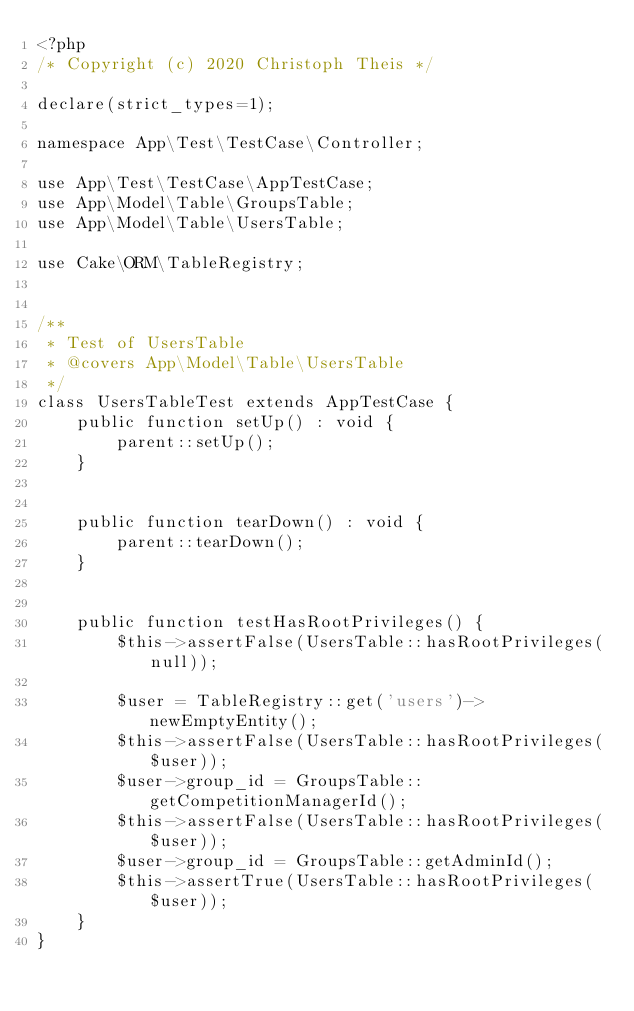Convert code to text. <code><loc_0><loc_0><loc_500><loc_500><_PHP_><?php
/* Copyright (c) 2020 Christoph Theis */

declare(strict_types=1);

namespace App\Test\TestCase\Controller;

use App\Test\TestCase\AppTestCase;
use App\Model\Table\GroupsTable;
use App\Model\Table\UsersTable;

use Cake\ORM\TableRegistry;


/**
 * Test of UsersTable
 * @covers App\Model\Table\UsersTable
 */
class UsersTableTest extends AppTestCase {
	public function setUp() : void {
		parent::setUp();
	}
	
	
	public function tearDown() : void {
		parent::tearDown();
	}
	
	
	public function testHasRootPrivileges() {
		$this->assertFalse(UsersTable::hasRootPrivileges(null));
		
		$user = TableRegistry::get('users')->newEmptyEntity();
		$this->assertFalse(UsersTable::hasRootPrivileges($user));
		$user->group_id = GroupsTable::getCompetitionManagerId();
		$this->assertFalse(UsersTable::hasRootPrivileges($user));
		$user->group_id = GroupsTable::getAdminId();
		$this->assertTrue(UsersTable::hasRootPrivileges($user));
	}	
}
</code> 